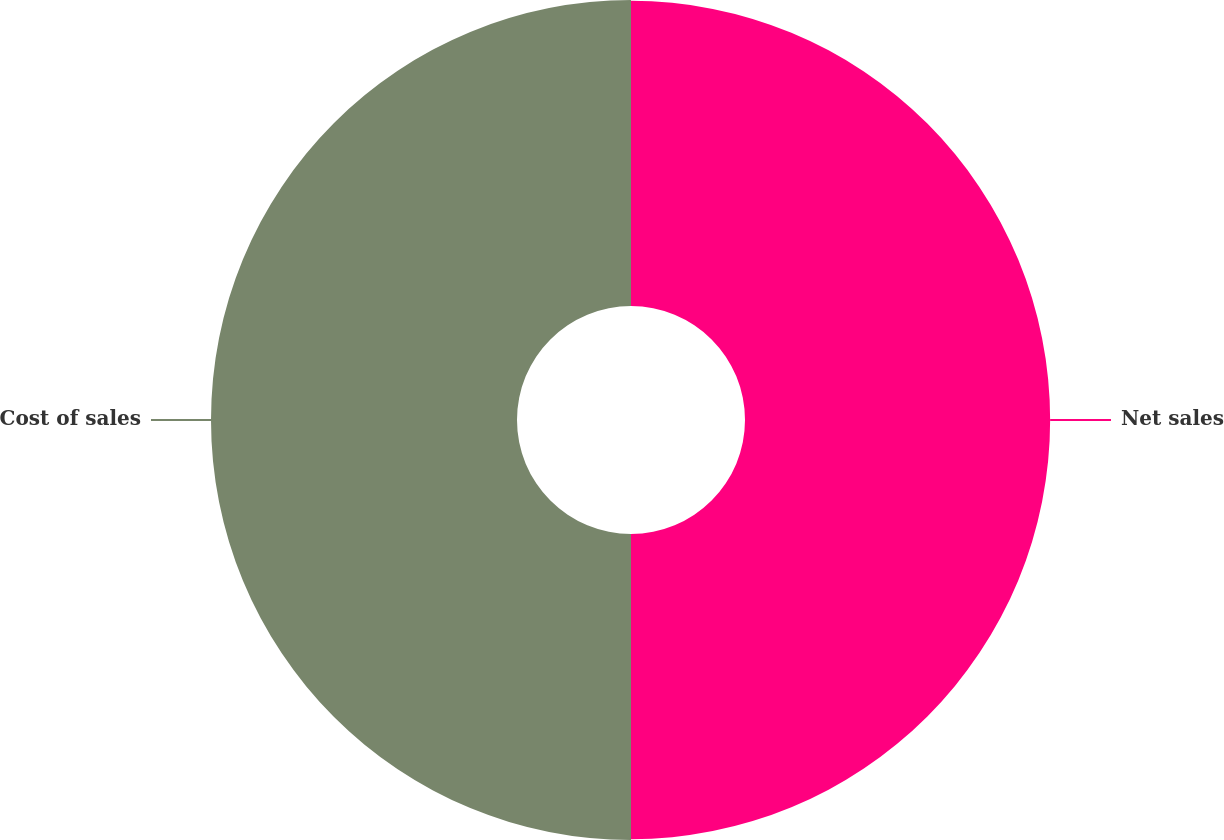Convert chart to OTSL. <chart><loc_0><loc_0><loc_500><loc_500><pie_chart><fcel>Net sales<fcel>Cost of sales<nl><fcel>49.93%<fcel>50.07%<nl></chart> 